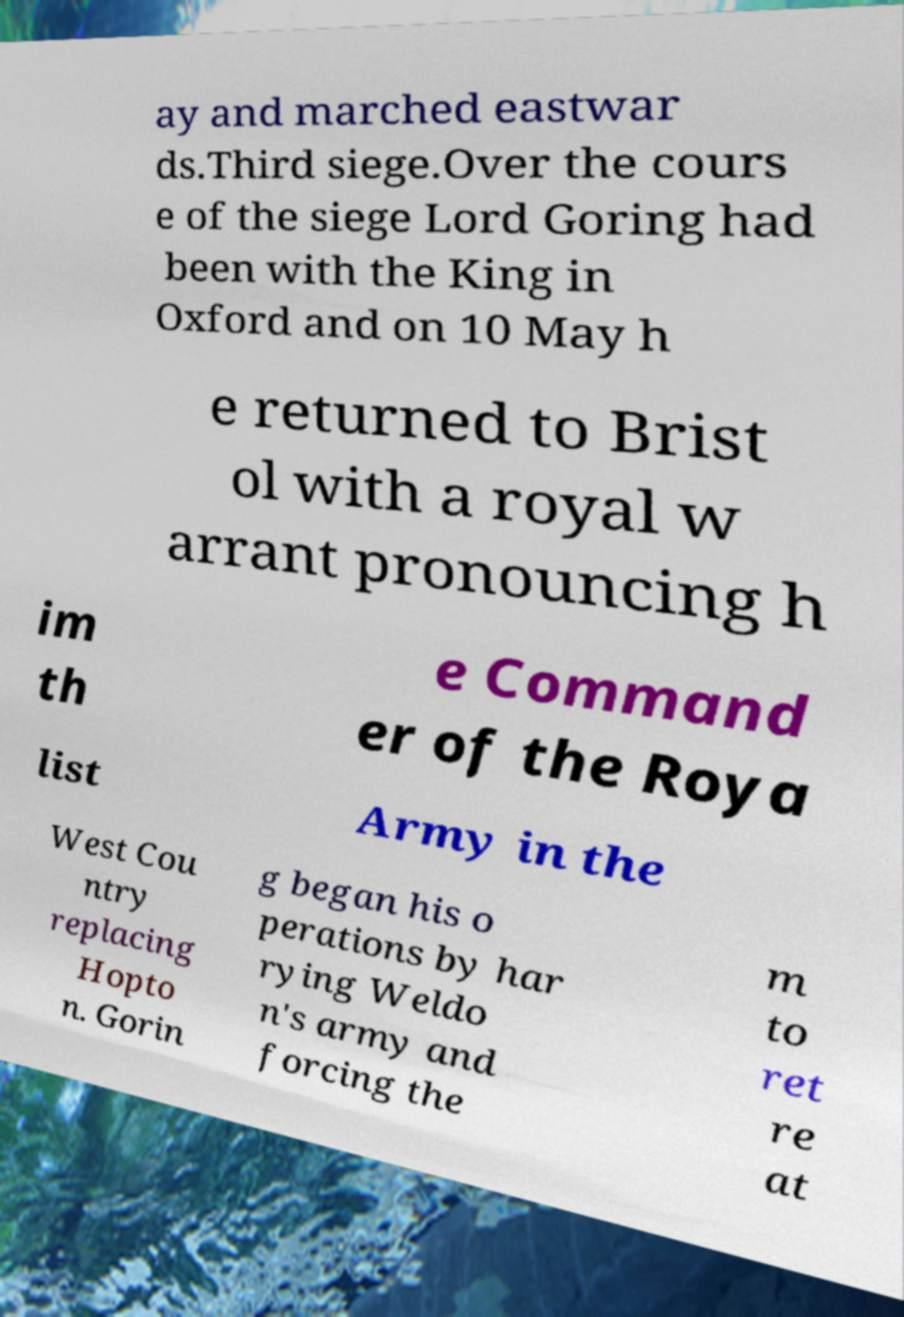What messages or text are displayed in this image? I need them in a readable, typed format. ay and marched eastwar ds.Third siege.Over the cours e of the siege Lord Goring had been with the King in Oxford and on 10 May h e returned to Brist ol with a royal w arrant pronouncing h im th e Command er of the Roya list Army in the West Cou ntry replacing Hopto n. Gorin g began his o perations by har rying Weldo n's army and forcing the m to ret re at 